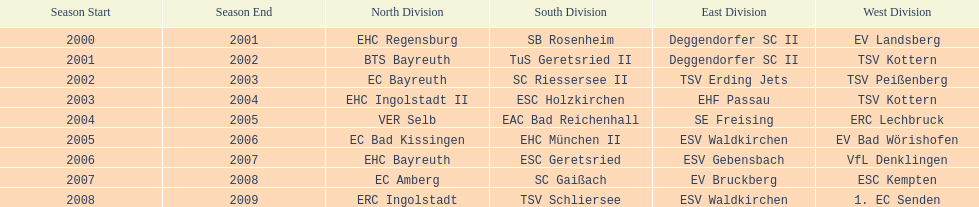How many champions are listend in the north? 9. 